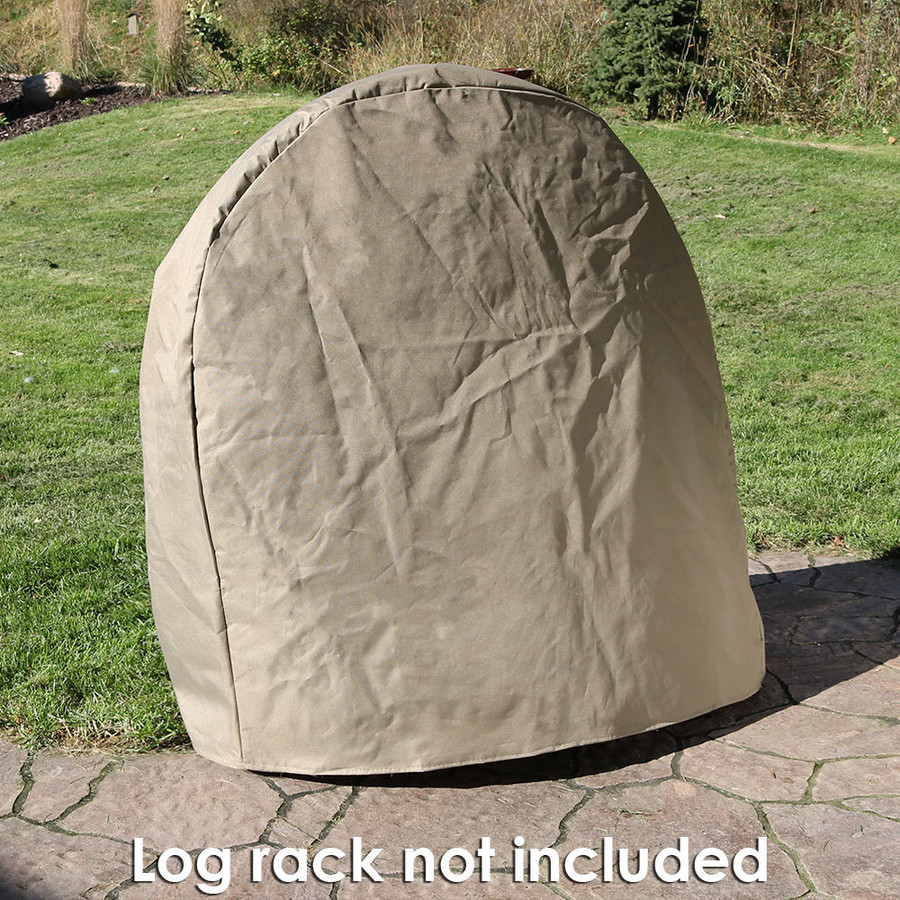Can we deduce the season during which this image was likely taken? By examining the image, we can infer the likely season based on several environmental clues. The lush greenery of the grass implies active plant growth typical of spring or summer. Additionally, the brightness of the environment and the stark shadows cast suggest that the sun is situated high in the sky, a common characteristic of the warmer months of the year. The absence of snow or fallen leaves further reinforces the estimation that it is neither winter nor autumn. Thus, it is reasonable to infer that the image was taken in either spring or summer, with additional considerations such as the type of vegetation and the specific sunlight intensity offering further clues. 